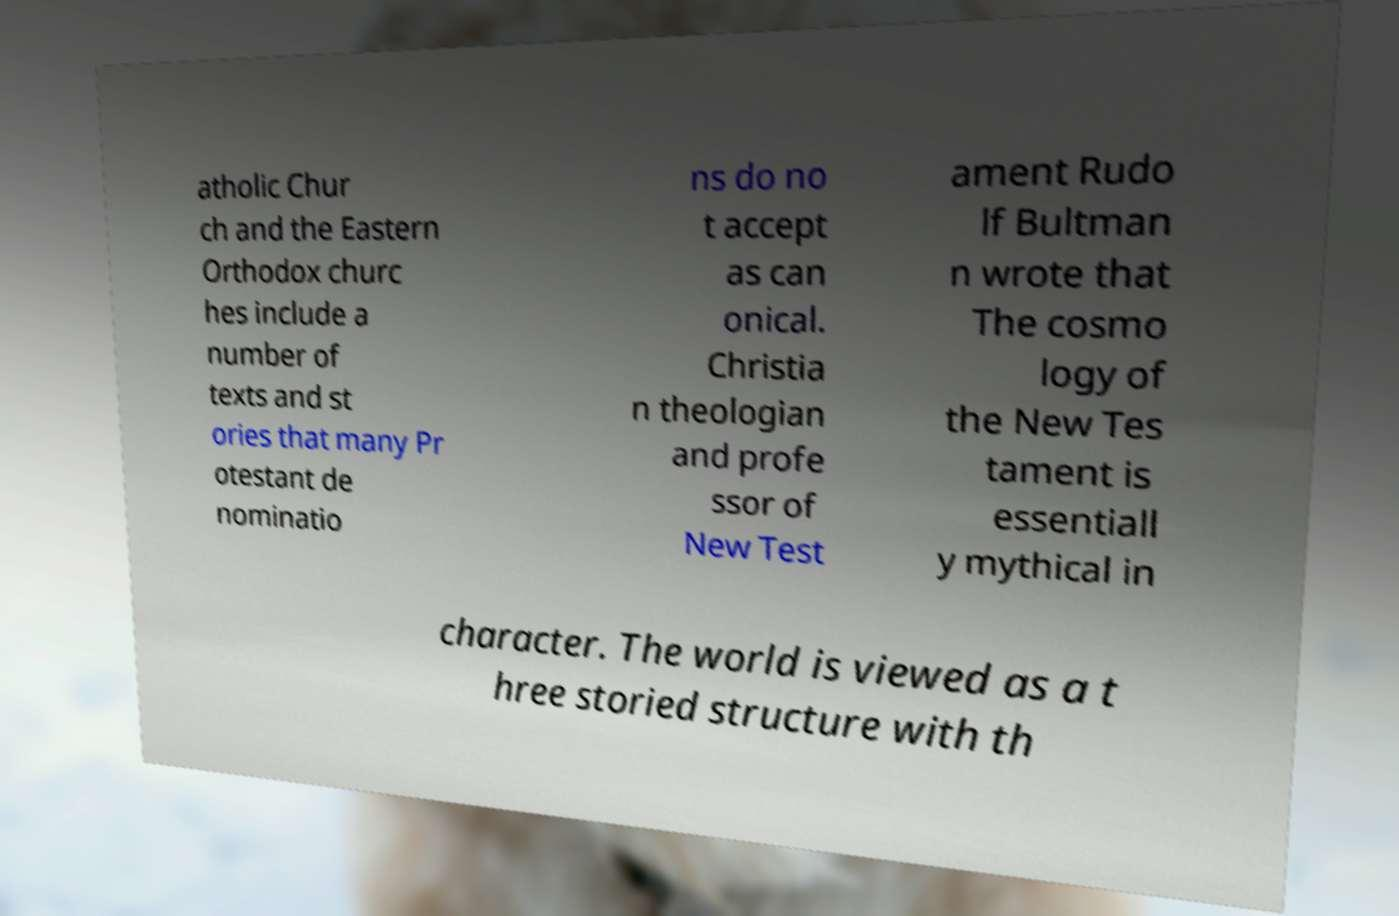Can you read and provide the text displayed in the image?This photo seems to have some interesting text. Can you extract and type it out for me? atholic Chur ch and the Eastern Orthodox churc hes include a number of texts and st ories that many Pr otestant de nominatio ns do no t accept as can onical. Christia n theologian and profe ssor of New Test ament Rudo lf Bultman n wrote that The cosmo logy of the New Tes tament is essentiall y mythical in character. The world is viewed as a t hree storied structure with th 